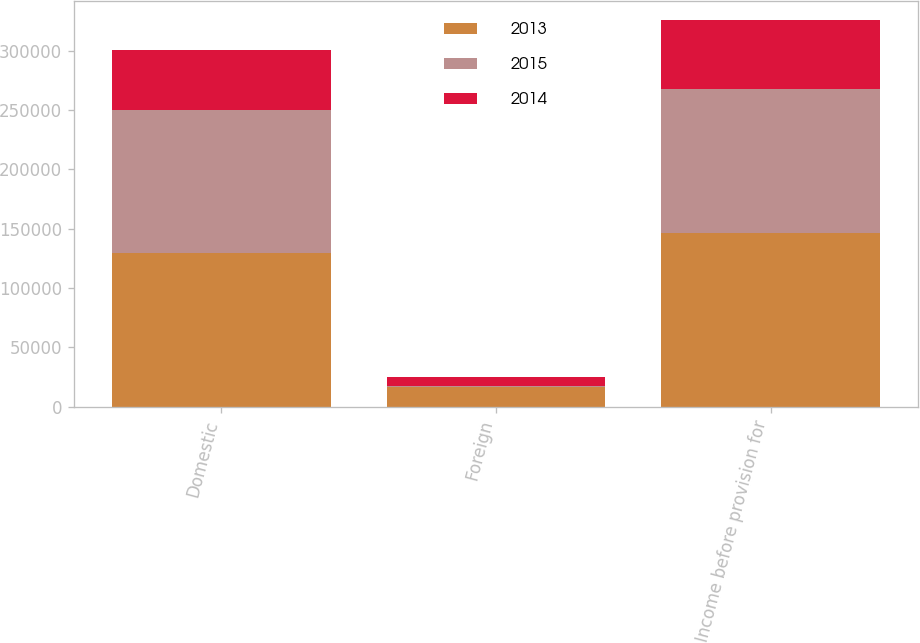Convert chart to OTSL. <chart><loc_0><loc_0><loc_500><loc_500><stacked_bar_chart><ecel><fcel>Domestic<fcel>Foreign<fcel>Income before provision for<nl><fcel>2013<fcel>129240<fcel>16769<fcel>146009<nl><fcel>2015<fcel>120838<fcel>670<fcel>121508<nl><fcel>2014<fcel>50455<fcel>7820<fcel>58275<nl></chart> 